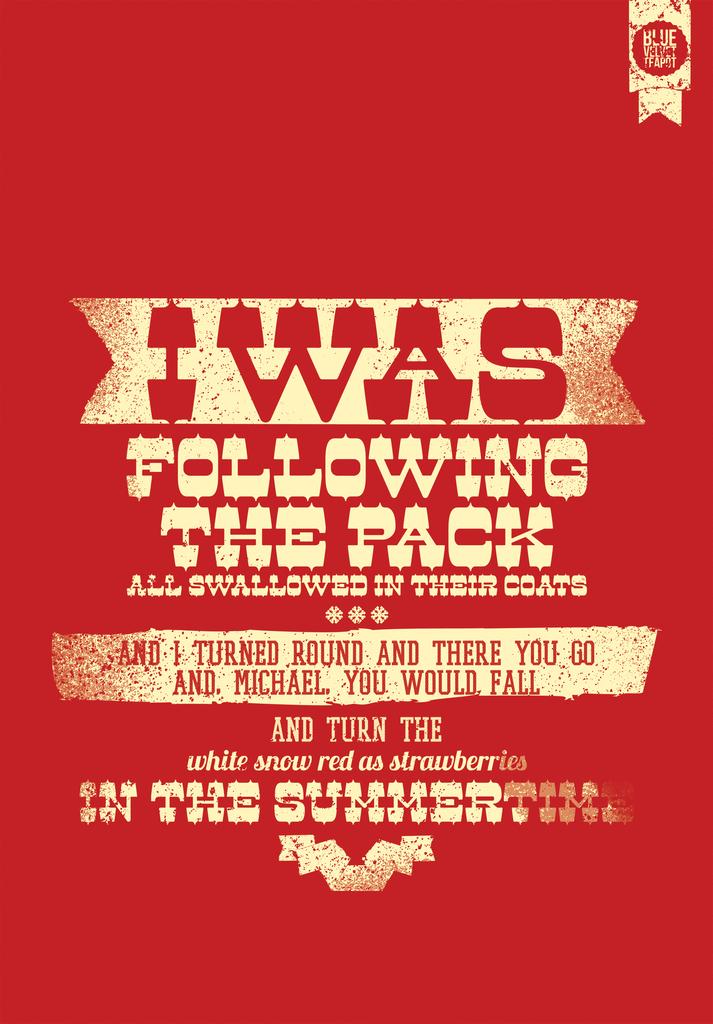Who was i following?
Offer a terse response. The pack. What is the season name denoted in this poster?
Offer a terse response. Summer. 